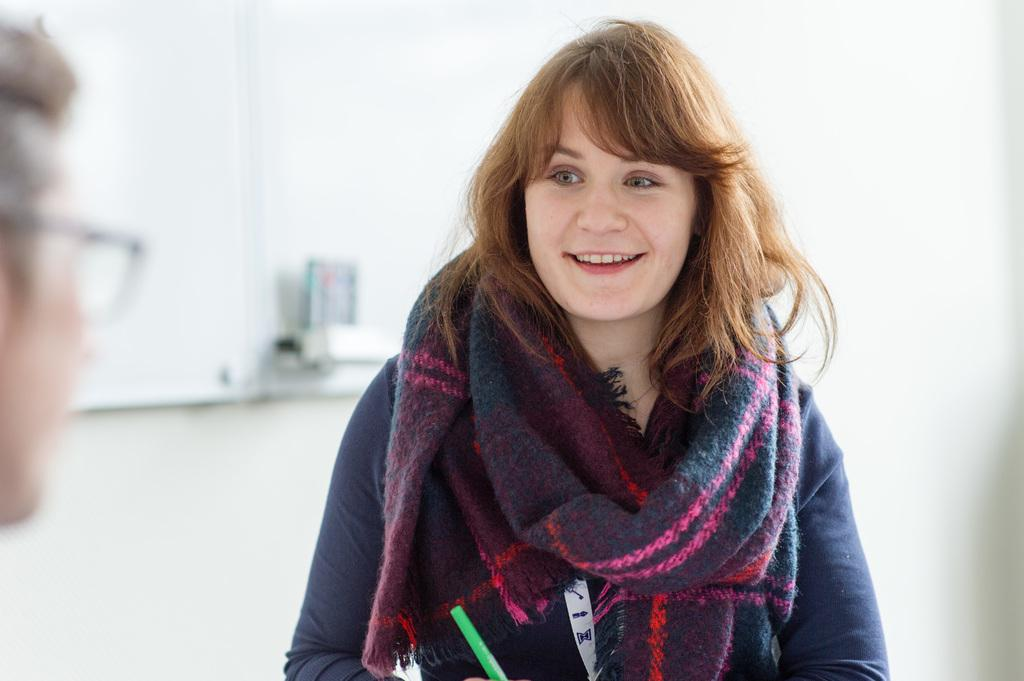How many people are in the image? There are two people in the image, a woman and a man. What type of polish is the goat wearing in the image? There is no goat present in the image, and therefore no polish or goat can be observed. 